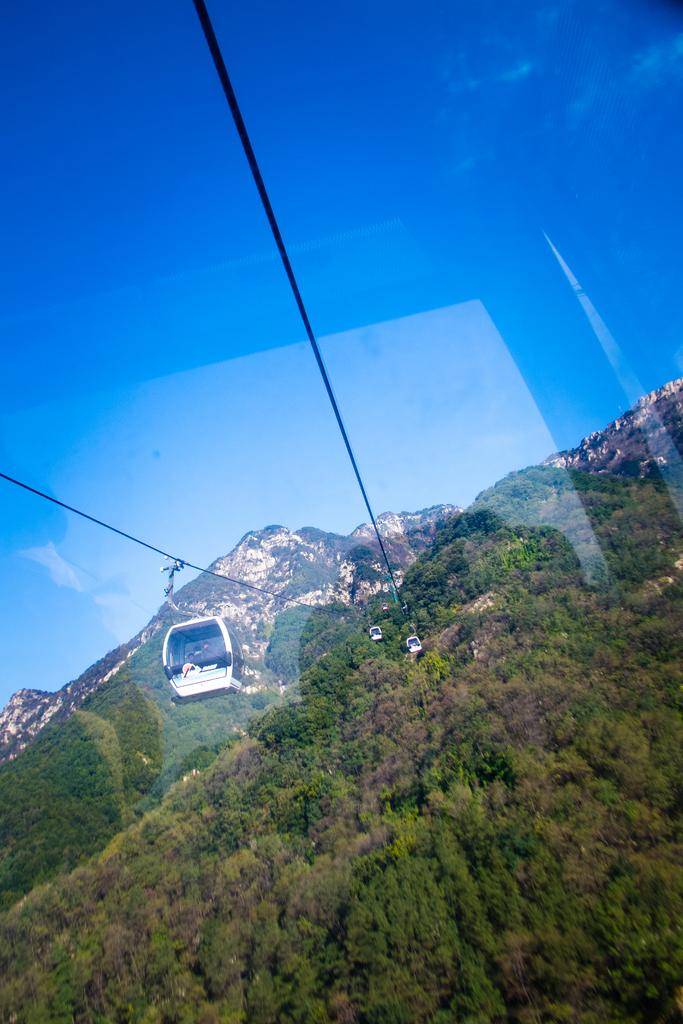What type of transportation can be seen in the image? There is a ropeway in the image. What is the condition of the sky in the image? The sky is clear and blue in the image. What type of natural environment is visible in the image? There are many trees and hills in the image. What type of playground equipment can be seen in the image? There is no playground equipment present in the image. What is the weight of the trees in the image? It is not possible to determine the weight of the trees in the image based solely on the image itself. 